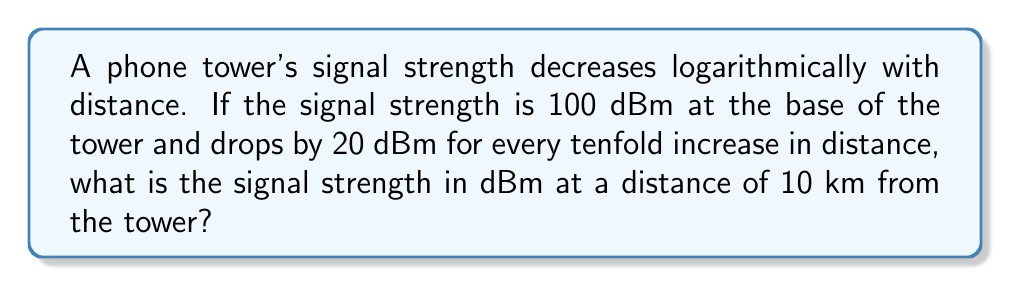Help me with this question. Let's approach this step-by-step:

1) First, we need to understand the logarithmic nature of the problem. The decibel scale is logarithmic, and the signal strength decreases by 20 dBm for every tenfold increase in distance.

2) We're given that the signal strength is 100 dBm at the base of the tower. Let's call this $S_0$.

   $S_0 = 100$ dBm

3) The signal strength at distance $d$ can be represented by the equation:

   $S(d) = S_0 - 20 \log_{10}(\frac{d}{d_0})$

   Where $d_0$ is the reference distance (1 meter in this case)

4) We're asked about the signal strength at 10 km, which is $10^4$ meters. Let's plug this into our equation:

   $S(10^4) = 100 - 20 \log_{10}(\frac{10^4}{1})$

5) Simplify:
   
   $S(10^4) = 100 - 20 \log_{10}(10^4)$
   
   $S(10^4) = 100 - 20 \cdot 4$
   
   $S(10^4) = 100 - 80$
   
   $S(10^4) = 20$ dBm

Therefore, the signal strength at 10 km from the tower is 20 dBm.
Answer: 20 dBm 